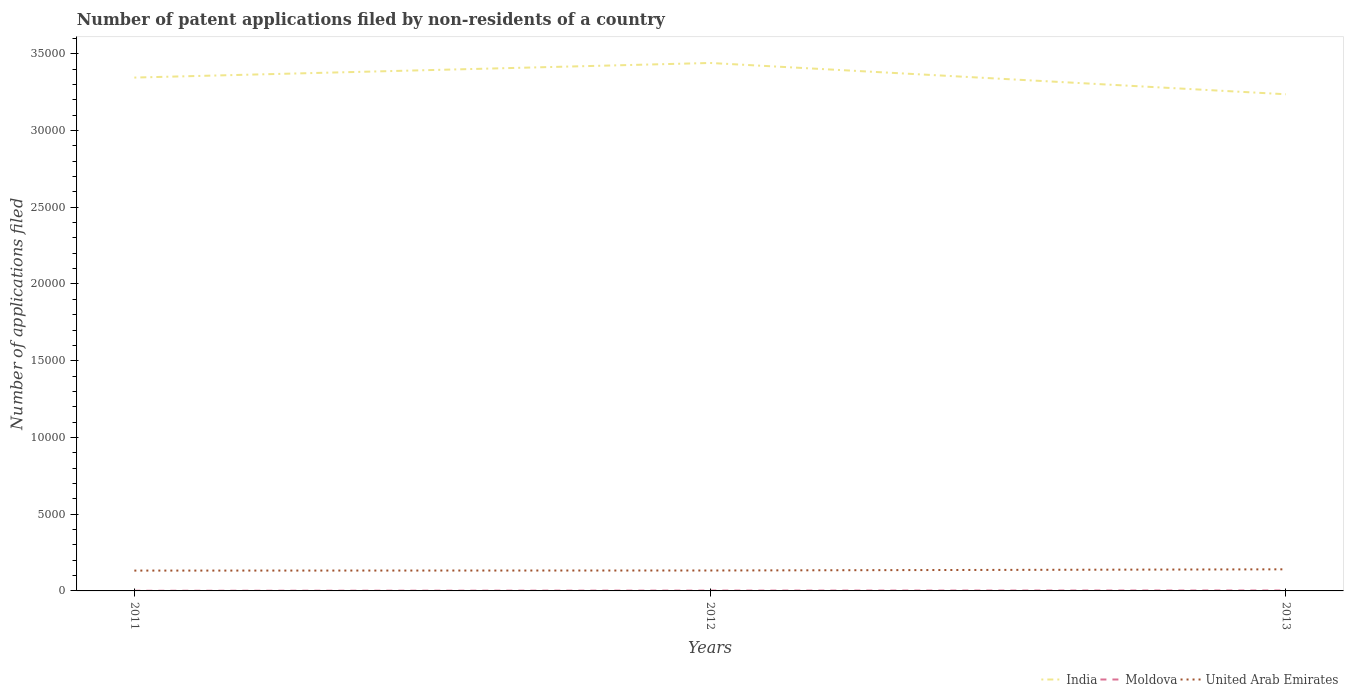How many different coloured lines are there?
Provide a short and direct response. 3. Does the line corresponding to United Arab Emirates intersect with the line corresponding to India?
Your answer should be compact. No. Across all years, what is the maximum number of applications filed in India?
Ensure brevity in your answer.  3.24e+04. What is the total number of applications filed in United Arab Emirates in the graph?
Your response must be concise. -77. What is the difference between the highest and the second highest number of applications filed in United Arab Emirates?
Provide a short and direct response. 83. What is the difference between the highest and the lowest number of applications filed in India?
Your answer should be compact. 2. How many lines are there?
Your response must be concise. 3. How many years are there in the graph?
Give a very brief answer. 3. Does the graph contain any zero values?
Ensure brevity in your answer.  No. Does the graph contain grids?
Provide a short and direct response. No. Where does the legend appear in the graph?
Offer a terse response. Bottom right. What is the title of the graph?
Offer a terse response. Number of patent applications filed by non-residents of a country. What is the label or title of the X-axis?
Your answer should be very brief. Years. What is the label or title of the Y-axis?
Keep it short and to the point. Number of applications filed. What is the Number of applications filed in India in 2011?
Make the answer very short. 3.34e+04. What is the Number of applications filed in Moldova in 2011?
Offer a very short reply. 11. What is the Number of applications filed of United Arab Emirates in 2011?
Ensure brevity in your answer.  1325. What is the Number of applications filed in India in 2012?
Offer a terse response. 3.44e+04. What is the Number of applications filed of Moldova in 2012?
Provide a succinct answer. 22. What is the Number of applications filed of United Arab Emirates in 2012?
Make the answer very short. 1331. What is the Number of applications filed in India in 2013?
Keep it short and to the point. 3.24e+04. What is the Number of applications filed in United Arab Emirates in 2013?
Your response must be concise. 1408. Across all years, what is the maximum Number of applications filed in India?
Your answer should be very brief. 3.44e+04. Across all years, what is the maximum Number of applications filed in United Arab Emirates?
Offer a terse response. 1408. Across all years, what is the minimum Number of applications filed of India?
Your response must be concise. 3.24e+04. Across all years, what is the minimum Number of applications filed in United Arab Emirates?
Offer a terse response. 1325. What is the total Number of applications filed of India in the graph?
Make the answer very short. 1.00e+05. What is the total Number of applications filed in Moldova in the graph?
Ensure brevity in your answer.  62. What is the total Number of applications filed in United Arab Emirates in the graph?
Offer a terse response. 4064. What is the difference between the Number of applications filed in India in 2011 and that in 2012?
Ensure brevity in your answer.  -952. What is the difference between the Number of applications filed of United Arab Emirates in 2011 and that in 2012?
Provide a short and direct response. -6. What is the difference between the Number of applications filed of India in 2011 and that in 2013?
Your response must be concise. 1088. What is the difference between the Number of applications filed in Moldova in 2011 and that in 2013?
Give a very brief answer. -18. What is the difference between the Number of applications filed of United Arab Emirates in 2011 and that in 2013?
Your response must be concise. -83. What is the difference between the Number of applications filed of India in 2012 and that in 2013?
Provide a short and direct response. 2040. What is the difference between the Number of applications filed in United Arab Emirates in 2012 and that in 2013?
Ensure brevity in your answer.  -77. What is the difference between the Number of applications filed in India in 2011 and the Number of applications filed in Moldova in 2012?
Ensure brevity in your answer.  3.34e+04. What is the difference between the Number of applications filed of India in 2011 and the Number of applications filed of United Arab Emirates in 2012?
Make the answer very short. 3.21e+04. What is the difference between the Number of applications filed in Moldova in 2011 and the Number of applications filed in United Arab Emirates in 2012?
Ensure brevity in your answer.  -1320. What is the difference between the Number of applications filed in India in 2011 and the Number of applications filed in Moldova in 2013?
Offer a very short reply. 3.34e+04. What is the difference between the Number of applications filed in India in 2011 and the Number of applications filed in United Arab Emirates in 2013?
Your answer should be very brief. 3.20e+04. What is the difference between the Number of applications filed in Moldova in 2011 and the Number of applications filed in United Arab Emirates in 2013?
Your answer should be very brief. -1397. What is the difference between the Number of applications filed of India in 2012 and the Number of applications filed of Moldova in 2013?
Make the answer very short. 3.44e+04. What is the difference between the Number of applications filed of India in 2012 and the Number of applications filed of United Arab Emirates in 2013?
Provide a succinct answer. 3.30e+04. What is the difference between the Number of applications filed in Moldova in 2012 and the Number of applications filed in United Arab Emirates in 2013?
Give a very brief answer. -1386. What is the average Number of applications filed in India per year?
Keep it short and to the point. 3.34e+04. What is the average Number of applications filed in Moldova per year?
Make the answer very short. 20.67. What is the average Number of applications filed in United Arab Emirates per year?
Make the answer very short. 1354.67. In the year 2011, what is the difference between the Number of applications filed in India and Number of applications filed in Moldova?
Provide a short and direct response. 3.34e+04. In the year 2011, what is the difference between the Number of applications filed in India and Number of applications filed in United Arab Emirates?
Ensure brevity in your answer.  3.21e+04. In the year 2011, what is the difference between the Number of applications filed of Moldova and Number of applications filed of United Arab Emirates?
Keep it short and to the point. -1314. In the year 2012, what is the difference between the Number of applications filed of India and Number of applications filed of Moldova?
Your response must be concise. 3.44e+04. In the year 2012, what is the difference between the Number of applications filed of India and Number of applications filed of United Arab Emirates?
Your answer should be very brief. 3.31e+04. In the year 2012, what is the difference between the Number of applications filed of Moldova and Number of applications filed of United Arab Emirates?
Provide a short and direct response. -1309. In the year 2013, what is the difference between the Number of applications filed of India and Number of applications filed of Moldova?
Offer a very short reply. 3.23e+04. In the year 2013, what is the difference between the Number of applications filed in India and Number of applications filed in United Arab Emirates?
Offer a terse response. 3.10e+04. In the year 2013, what is the difference between the Number of applications filed in Moldova and Number of applications filed in United Arab Emirates?
Offer a terse response. -1379. What is the ratio of the Number of applications filed of India in 2011 to that in 2012?
Ensure brevity in your answer.  0.97. What is the ratio of the Number of applications filed in United Arab Emirates in 2011 to that in 2012?
Your response must be concise. 1. What is the ratio of the Number of applications filed in India in 2011 to that in 2013?
Your response must be concise. 1.03. What is the ratio of the Number of applications filed of Moldova in 2011 to that in 2013?
Ensure brevity in your answer.  0.38. What is the ratio of the Number of applications filed in United Arab Emirates in 2011 to that in 2013?
Offer a very short reply. 0.94. What is the ratio of the Number of applications filed in India in 2012 to that in 2013?
Ensure brevity in your answer.  1.06. What is the ratio of the Number of applications filed of Moldova in 2012 to that in 2013?
Your response must be concise. 0.76. What is the ratio of the Number of applications filed of United Arab Emirates in 2012 to that in 2013?
Offer a terse response. 0.95. What is the difference between the highest and the second highest Number of applications filed in India?
Your answer should be very brief. 952. What is the difference between the highest and the second highest Number of applications filed of Moldova?
Your response must be concise. 7. What is the difference between the highest and the lowest Number of applications filed of India?
Your response must be concise. 2040. What is the difference between the highest and the lowest Number of applications filed in United Arab Emirates?
Your answer should be very brief. 83. 